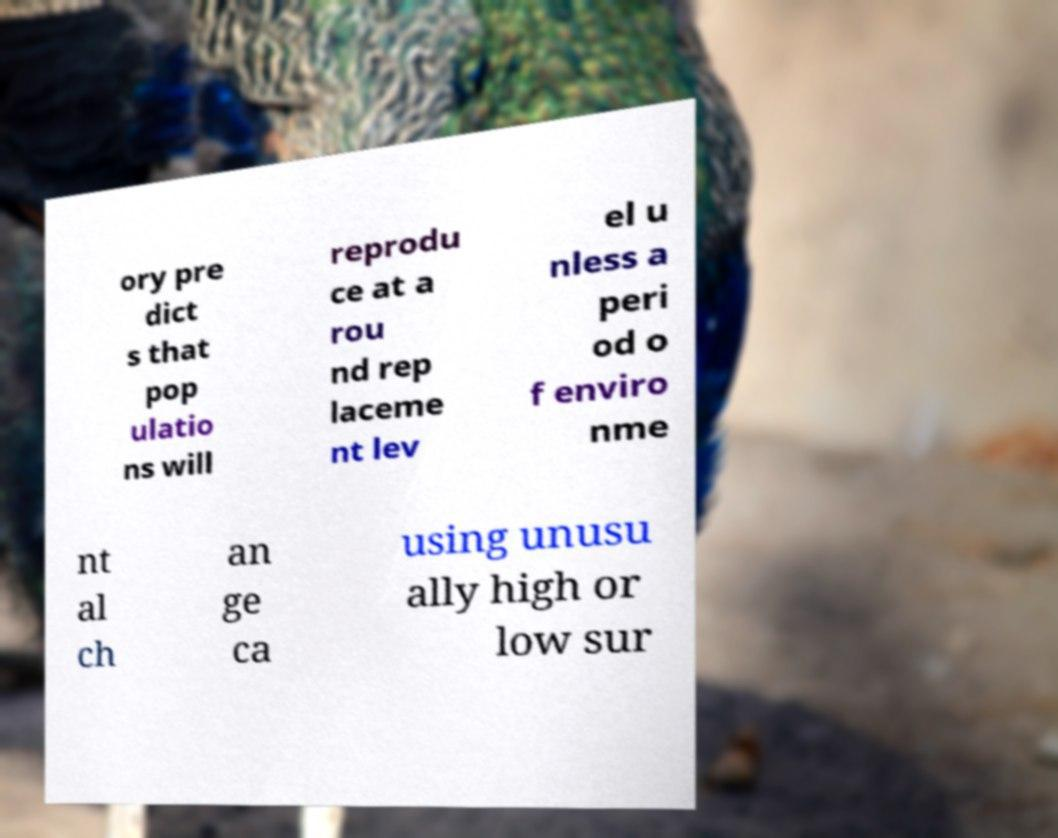There's text embedded in this image that I need extracted. Can you transcribe it verbatim? ory pre dict s that pop ulatio ns will reprodu ce at a rou nd rep laceme nt lev el u nless a peri od o f enviro nme nt al ch an ge ca using unusu ally high or low sur 